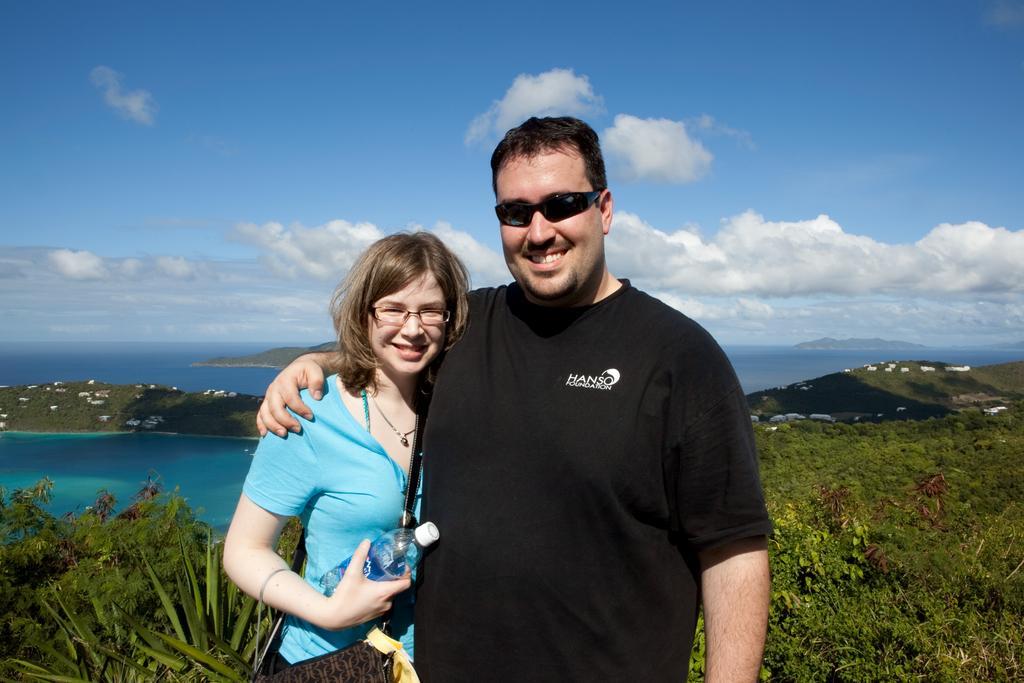Please provide a concise description of this image. In this image I can see a woman and a man. I can see the grass. In the background, I can see the water, trees and clouds in the sky. 